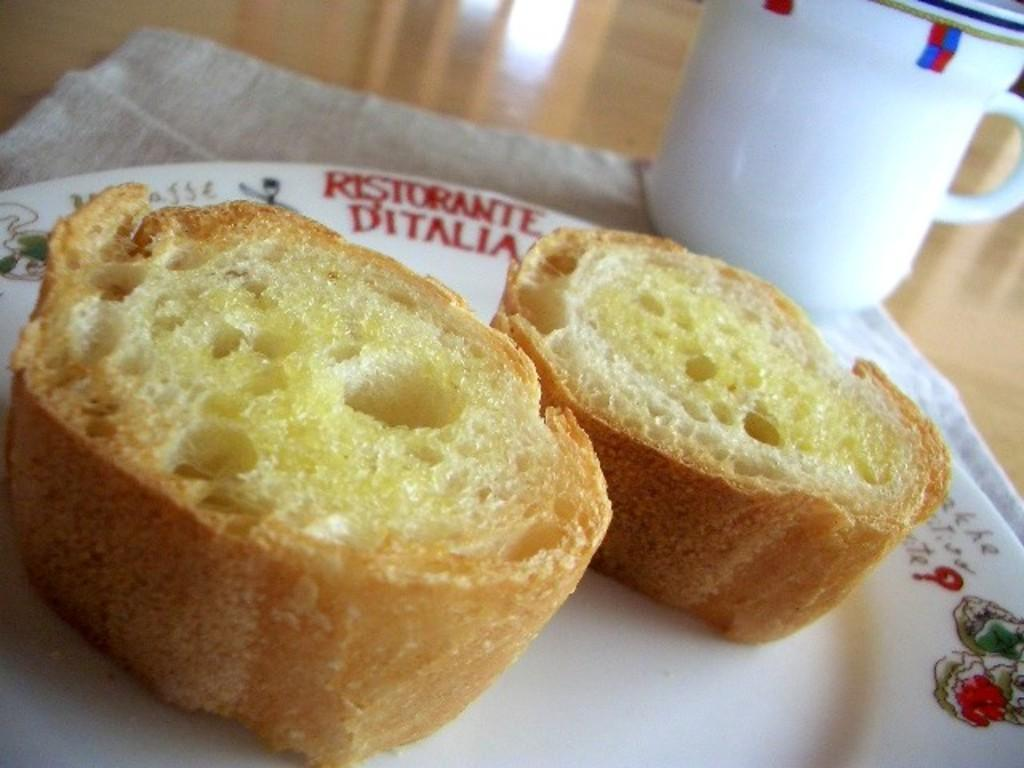What is on the plate in the image? There is food on the plate in the image. What is located next to the plate in the image? There is a cup beside the plate in the image. What type of soap is being used to clean the governor's hands in the image? There is no soap or governor present in the image; it only features a plate with food and a cup beside it. 